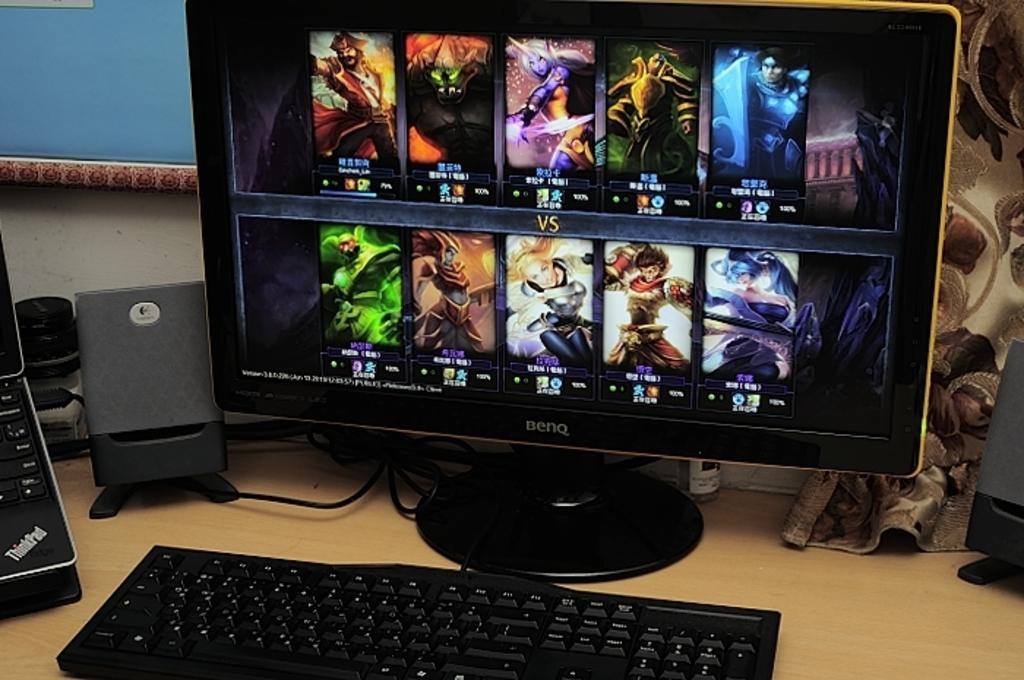<image>
Write a terse but informative summary of the picture. The brand of the computer monitor is BENQ. 